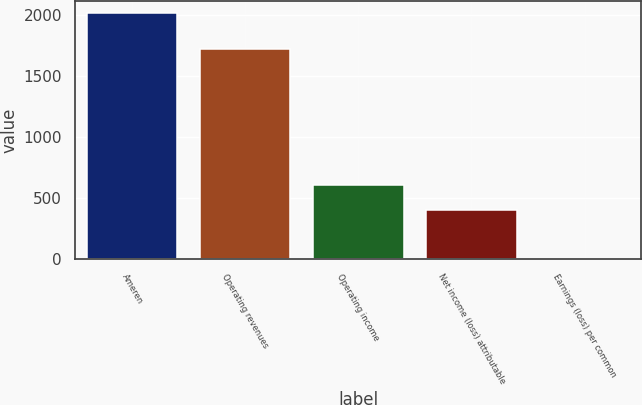Convert chart to OTSL. <chart><loc_0><loc_0><loc_500><loc_500><bar_chart><fcel>Ameren<fcel>Operating revenues<fcel>Operating income<fcel>Net income (loss) attributable<fcel>Earnings (loss) per common<nl><fcel>2017<fcel>1723<fcel>605.92<fcel>404.34<fcel>1.18<nl></chart> 